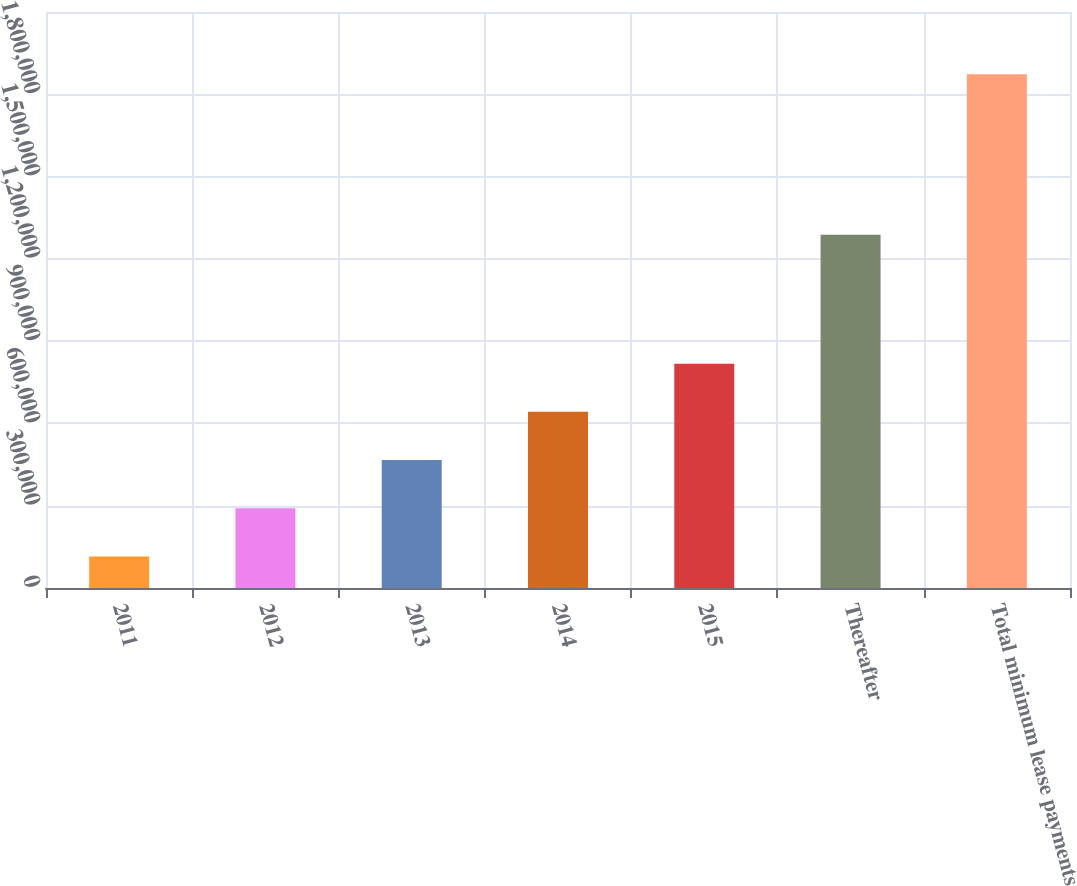Convert chart to OTSL. <chart><loc_0><loc_0><loc_500><loc_500><bar_chart><fcel>2011<fcel>2012<fcel>2013<fcel>2014<fcel>2015<fcel>Thereafter<fcel>Total minimum lease payments<nl><fcel>114754<fcel>290566<fcel>466378<fcel>642189<fcel>818001<fcel>1.28809e+06<fcel>1.87287e+06<nl></chart> 